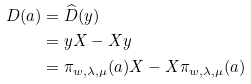<formula> <loc_0><loc_0><loc_500><loc_500>D ( a ) & = \widehat { D } ( y ) \\ & = y X - X y \\ & = \pi _ { w , \lambda , \mu } ( a ) X - X \pi _ { w , \lambda , \mu } ( a )</formula> 